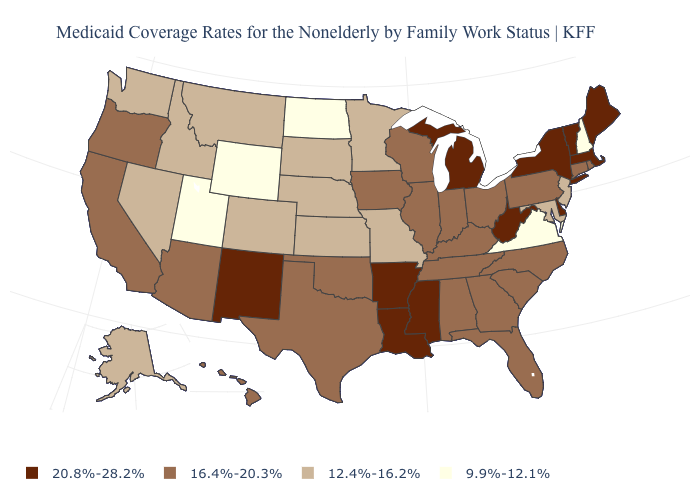What is the lowest value in states that border North Dakota?
Quick response, please. 12.4%-16.2%. What is the value of Pennsylvania?
Give a very brief answer. 16.4%-20.3%. Name the states that have a value in the range 12.4%-16.2%?
Write a very short answer. Alaska, Colorado, Idaho, Kansas, Maryland, Minnesota, Missouri, Montana, Nebraska, Nevada, New Jersey, South Dakota, Washington. What is the value of Montana?
Give a very brief answer. 12.4%-16.2%. Among the states that border Oklahoma , does Colorado have the lowest value?
Answer briefly. Yes. What is the value of Delaware?
Concise answer only. 20.8%-28.2%. Which states hav the highest value in the South?
Short answer required. Arkansas, Delaware, Louisiana, Mississippi, West Virginia. Name the states that have a value in the range 9.9%-12.1%?
Be succinct. New Hampshire, North Dakota, Utah, Virginia, Wyoming. Name the states that have a value in the range 20.8%-28.2%?
Keep it brief. Arkansas, Delaware, Louisiana, Maine, Massachusetts, Michigan, Mississippi, New Mexico, New York, Vermont, West Virginia. What is the value of Louisiana?
Short answer required. 20.8%-28.2%. What is the lowest value in the USA?
Answer briefly. 9.9%-12.1%. Does Oregon have a higher value than Alabama?
Give a very brief answer. No. Does the first symbol in the legend represent the smallest category?
Answer briefly. No. Does Georgia have the same value as Kansas?
Answer briefly. No. 